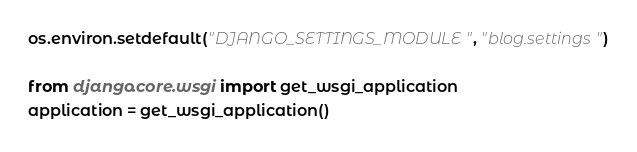Convert code to text. <code><loc_0><loc_0><loc_500><loc_500><_Python_>os.environ.setdefault("DJANGO_SETTINGS_MODULE", "blog.settings")

from django.core.wsgi import get_wsgi_application
application = get_wsgi_application()
</code> 